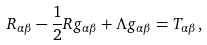Convert formula to latex. <formula><loc_0><loc_0><loc_500><loc_500>R _ { \alpha \beta } - \frac { 1 } { 2 } R g _ { \alpha \beta } + \Lambda g _ { \alpha \beta } = T _ { \alpha \beta } ,</formula> 